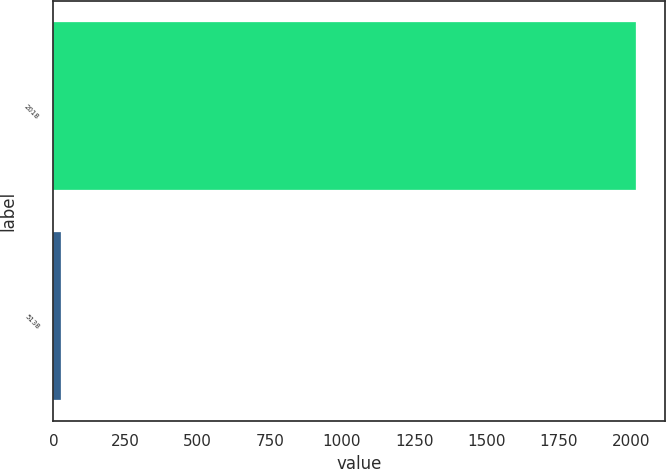Convert chart to OTSL. <chart><loc_0><loc_0><loc_500><loc_500><bar_chart><fcel>2018<fcel>5138<nl><fcel>2018<fcel>26<nl></chart> 